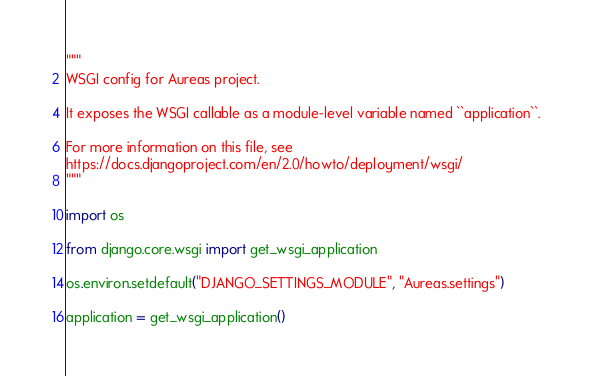Convert code to text. <code><loc_0><loc_0><loc_500><loc_500><_Python_>"""
WSGI config for Aureas project.

It exposes the WSGI callable as a module-level variable named ``application``.

For more information on this file, see
https://docs.djangoproject.com/en/2.0/howto/deployment/wsgi/
"""

import os

from django.core.wsgi import get_wsgi_application

os.environ.setdefault("DJANGO_SETTINGS_MODULE", "Aureas.settings")

application = get_wsgi_application()
</code> 